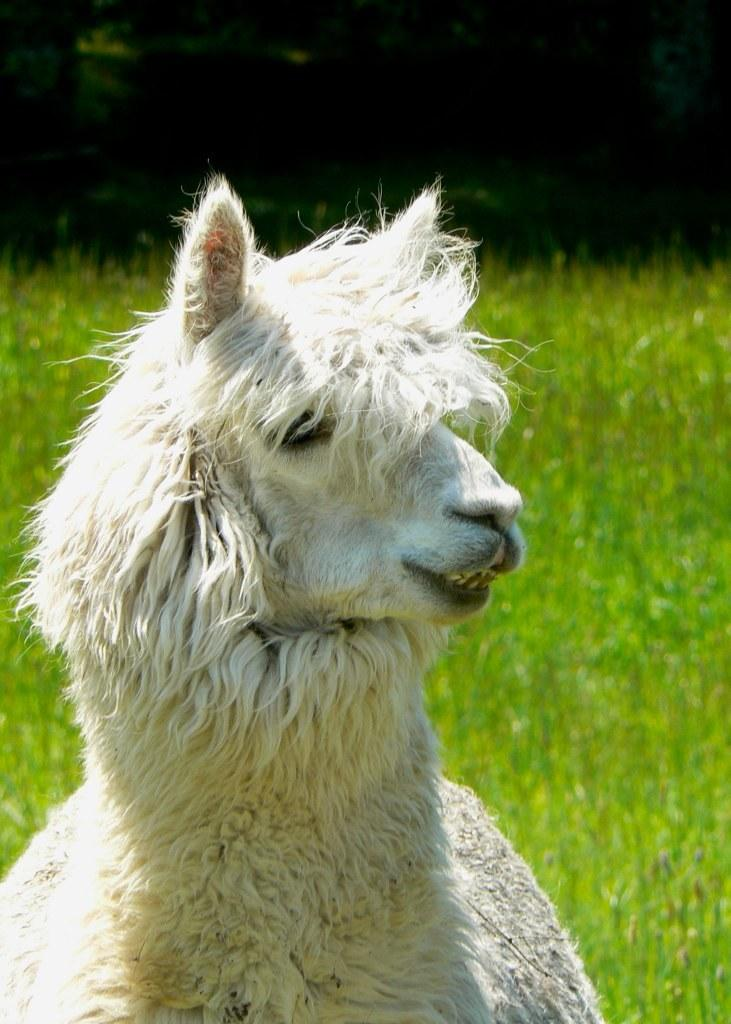What type of animal is in the image? The animal in the image is white in color. What is the background of the image? There is a green grassy land in the image. What type of secretary is working in the field in the image? There is no secretary or field present in the image; it features a white animal on a green grassy land. 